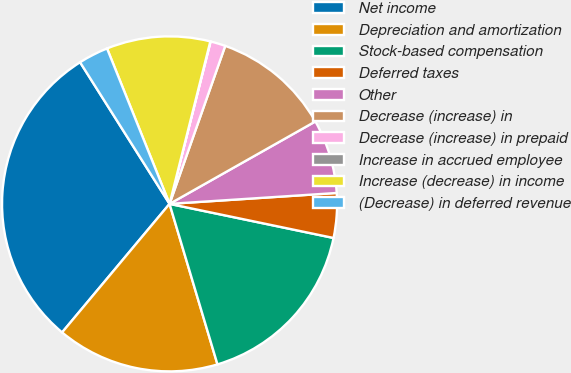Convert chart to OTSL. <chart><loc_0><loc_0><loc_500><loc_500><pie_chart><fcel>Net income<fcel>Depreciation and amortization<fcel>Stock-based compensation<fcel>Deferred taxes<fcel>Other<fcel>Decrease (increase) in<fcel>Decrease (increase) in prepaid<fcel>Increase in accrued employee<fcel>Increase (decrease) in income<fcel>(Decrease) in deferred revenue<nl><fcel>29.95%<fcel>15.7%<fcel>17.12%<fcel>4.3%<fcel>7.15%<fcel>11.42%<fcel>1.45%<fcel>0.03%<fcel>10.0%<fcel>2.88%<nl></chart> 